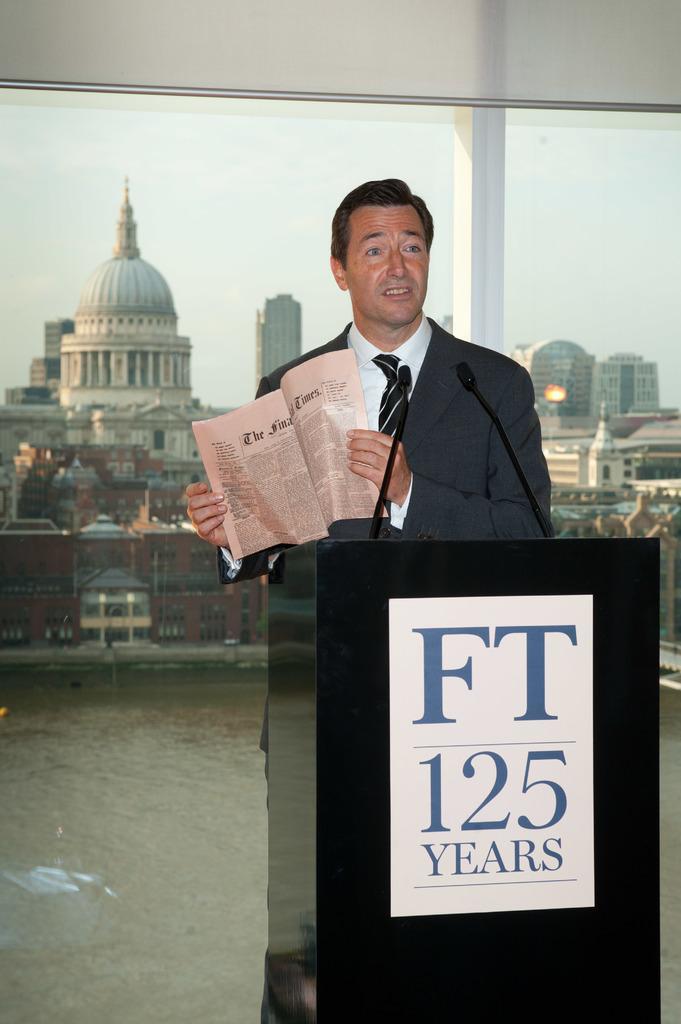Can you describe this image briefly? In this image I can see the person standing and holding the paper. In front I can see the podium and two microphones. In the background I can see the glass wall, few buildings, lights and the water and the sky is in white color. 